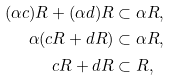Convert formula to latex. <formula><loc_0><loc_0><loc_500><loc_500>( \alpha c ) R + ( \alpha d ) R & \subset \alpha R , \\ \alpha ( c R + d R ) & \subset \alpha R , \\ c R + d R & \subset R ,</formula> 